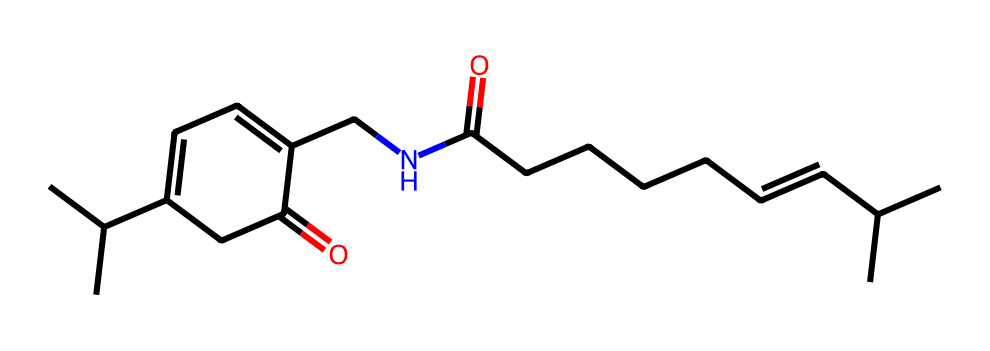How many carbon atoms are in capsaicin? By examining the SMILES representation, we can identify "C" which stands for carbon; counting each distinct "C" yields a total of 18 carbon atoms in the chemical structure of capsaicin.
Answer: 18 What type of functional groups are present in capsaicin? Analyzing the SMILES, we can see groups such as an amide ("C(=O)N"), indicating the presence of a carbonyl (C=O) and nitrogen (N) bond, along with a hydroxyl group (-OH) associated with the aromatic ring structure.
Answer: amide, hydroxyl Which part of the chemical structure is responsible for its pungency? The presence of the nitrogen atom in the amide group contributes to the pungency of capsaicin as it is involved in the chemical interactions that activate pain receptors, leading to the sensation of heat or spiciness.
Answer: nitrogen atom How many double bonds are present in the capsaicin structure? By closely inspecting the SMILES representation, we can find 2 double bonds within the structure (C=C), clearly indicated in the sections "/C=C/". Thus, capsaicin contains two double bonds.
Answer: 2 What is the total number of oxygen atoms present in capsaicin? In the provided SMILES structure, we can clearly identify the oxygen atoms represented by the "O" characters, which reveals there are a total of 3 oxygen atoms in the chemical structure of capsaicin.
Answer: 3 Is capsaicin a saturated or unsaturated hydrocarbon? Considering the presence of double bonds (C=C) in the molecular structure of capsaicin from the SMILES, it is classified as an unsaturated hydrocarbon because it contains at least one double bond.
Answer: unsaturated 